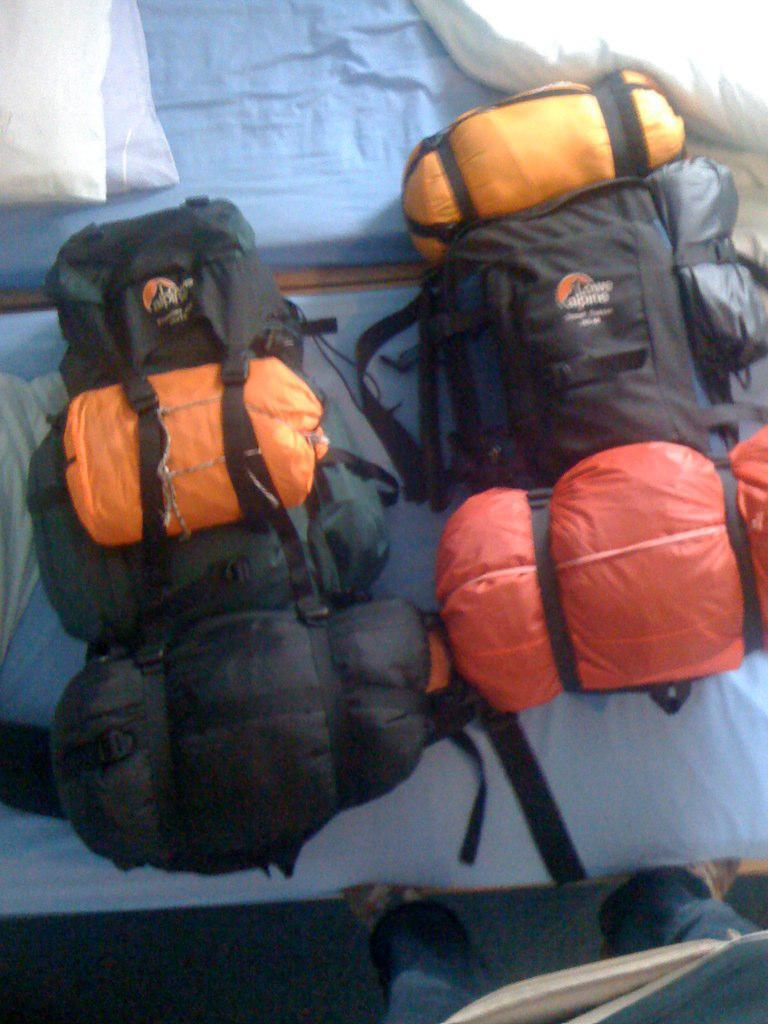How many backpacks are visible in the image? There are two backpacks in the image. Where are the backpacks located? The backpacks are on a bed. What type of mark can be seen on the field in the image? There is no field present in the image; it only features two backpacks on a bed. How many boys are visible in the image? There are no boys present in the image; it only features two backpacks on a bed. 